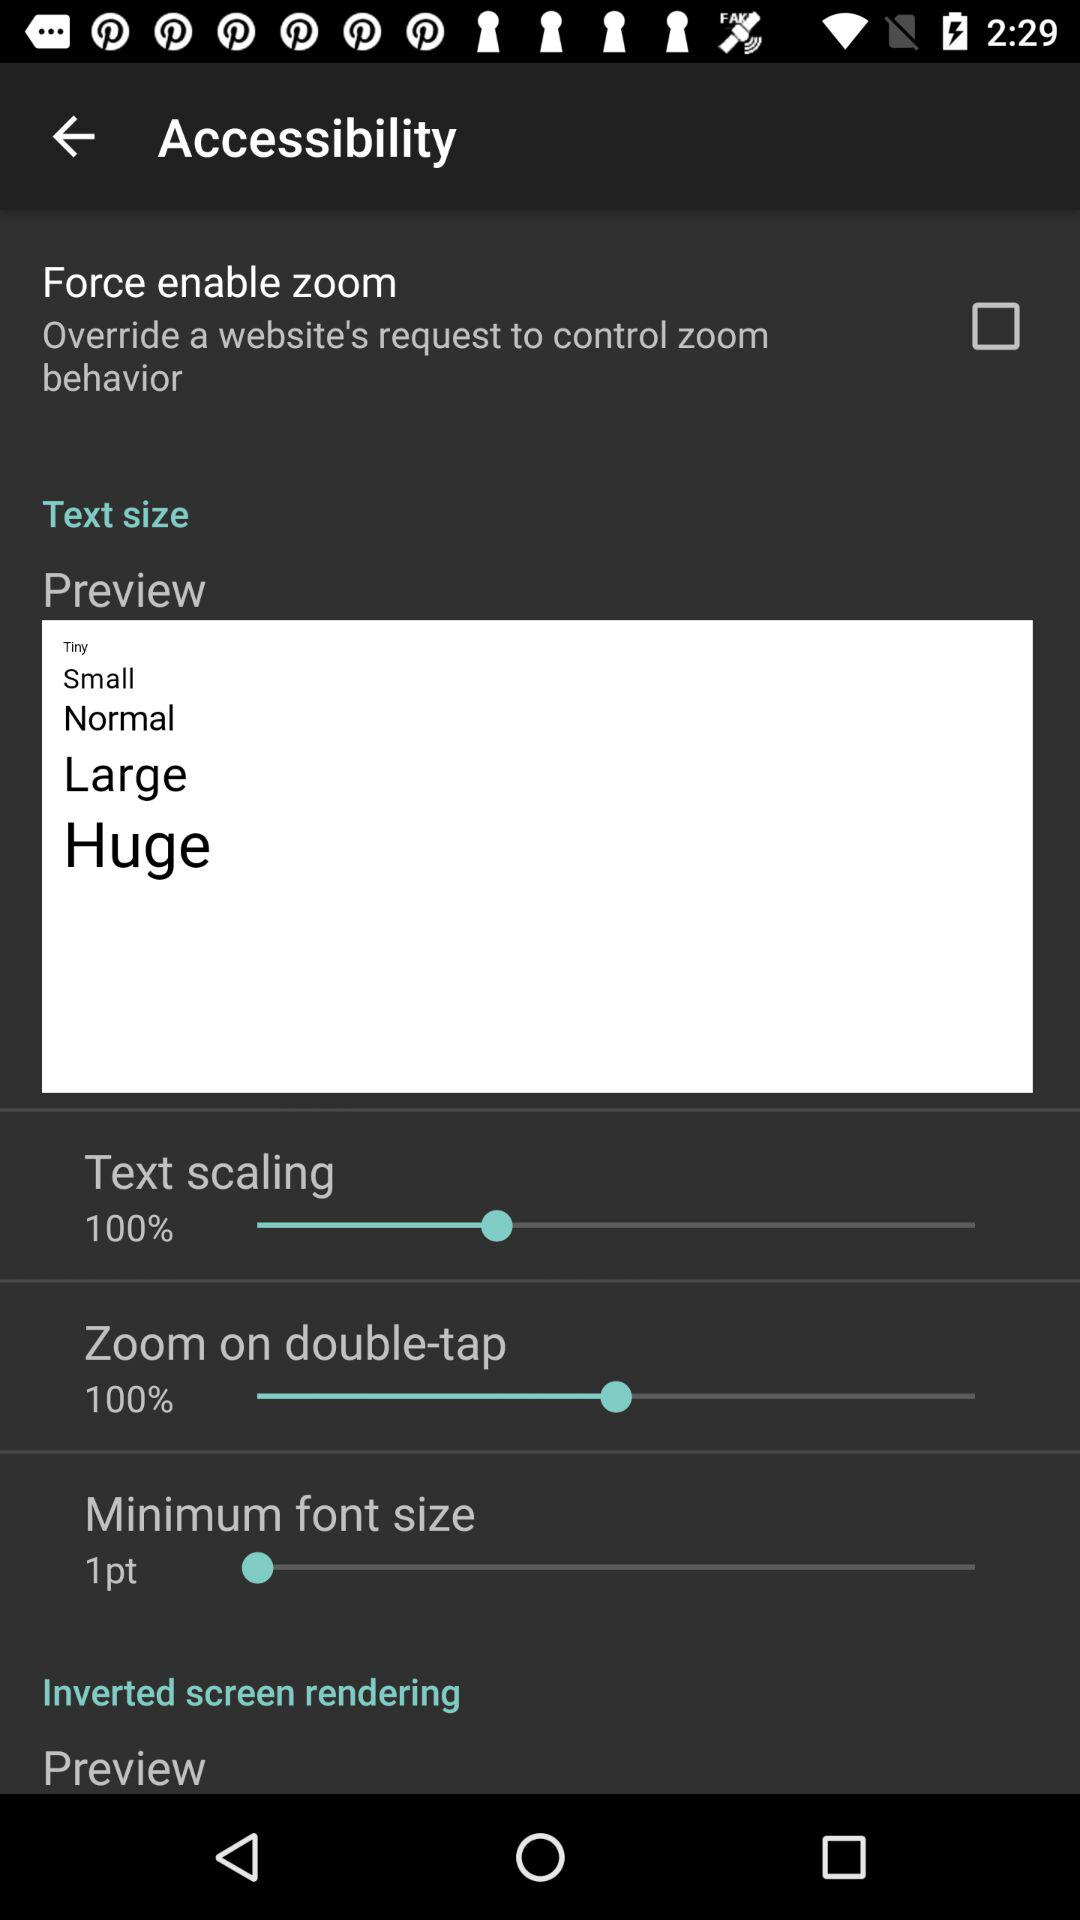What's the minimum font size? The minimum font size is 1 point. 